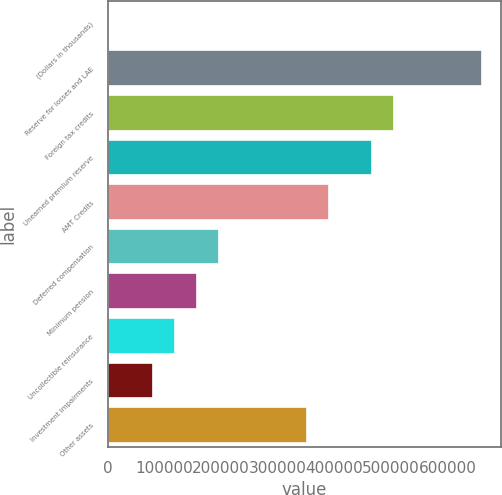<chart> <loc_0><loc_0><loc_500><loc_500><bar_chart><fcel>(Dollars in thousands)<fcel>Reserve for losses and LAE<fcel>Foreign tax credits<fcel>Unearned premium reserve<fcel>AMT Credits<fcel>Deferred compensation<fcel>Minimum pension<fcel>Uncollectible reinsurance<fcel>Investment impairments<fcel>Other assets<nl><fcel>2010<fcel>661323<fcel>506190<fcel>467407<fcel>389841<fcel>195926<fcel>157142<fcel>118359<fcel>79576.2<fcel>351058<nl></chart> 